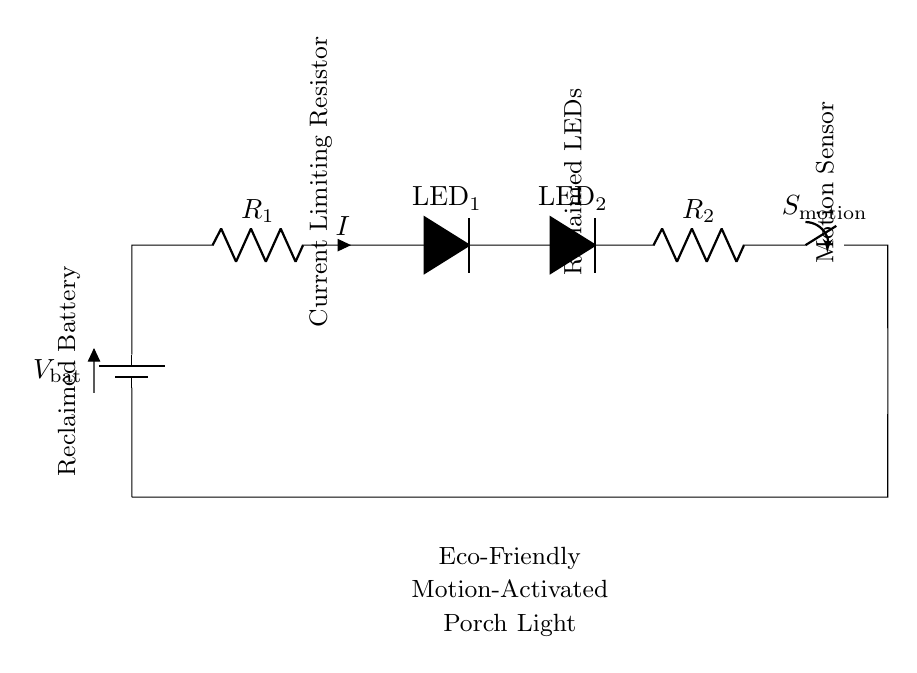What is the power source in this circuit? The power source is indicated as a battery. The symbol used represents a battery, and it is labeled as "V_bat."
Answer: battery How many LEDs are present in this circuit? Two LED components are shown in the circuit diagram, with labels as "LED_1" and "LED_2."
Answer: two What is the function of the switch in the circuit? The switch, labeled "S_motion," serves to control the activation of the circuit based on motion detection. When closed, it allows current to flow, illuminating the LEDs.
Answer: motion activation What is the role of resistor R1? Resistor R1 is a current limiting resistor, which helps to control the amount of current flowing through the LEDs, preventing them from being damaged by excess current.
Answer: current limiting What happens when the motion sensor is activated? When the motion sensor is activated (the switch is closed), current can flow through the circuit, powering the LEDs and causing them to light up.
Answer: LEDs illuminate What is the function of resistor R2 in this circuit? Resistor R2 is likely another current limiting resistor, potentially used to work in conjunction with R1 for adjusting the brightness or ensuring proper operation of the LEDs under varying voltage conditions.
Answer: another current limiting resistor What is the orientation of the current flow in the circuit? Current flows from the positive terminal of the battery, through the resistors and LEDs, and finally into the motion sensor before returning to the battery. The arrows indicating current direction throughout the circuit imply this flow.
Answer: from battery to circuit components 